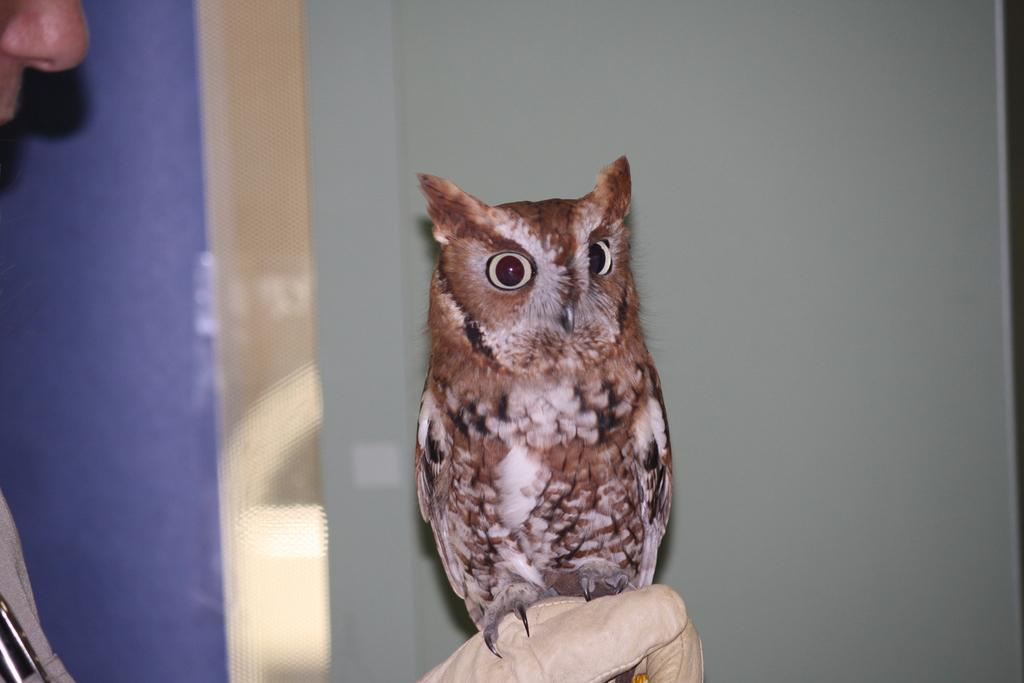What type of bird is in the picture? There is a brown color owl in the picture. What is the owl doing in the picture? The owl is sitting on a man's hand. What can be seen in the background of the picture? There is a grey color wall in the background of the picture. What type of alarm is the owl using to wake up the laborer in the picture? There is no alarm or laborer present in the image; it features a brown color owl sitting on a man's hand with a grey color wall in the background. 